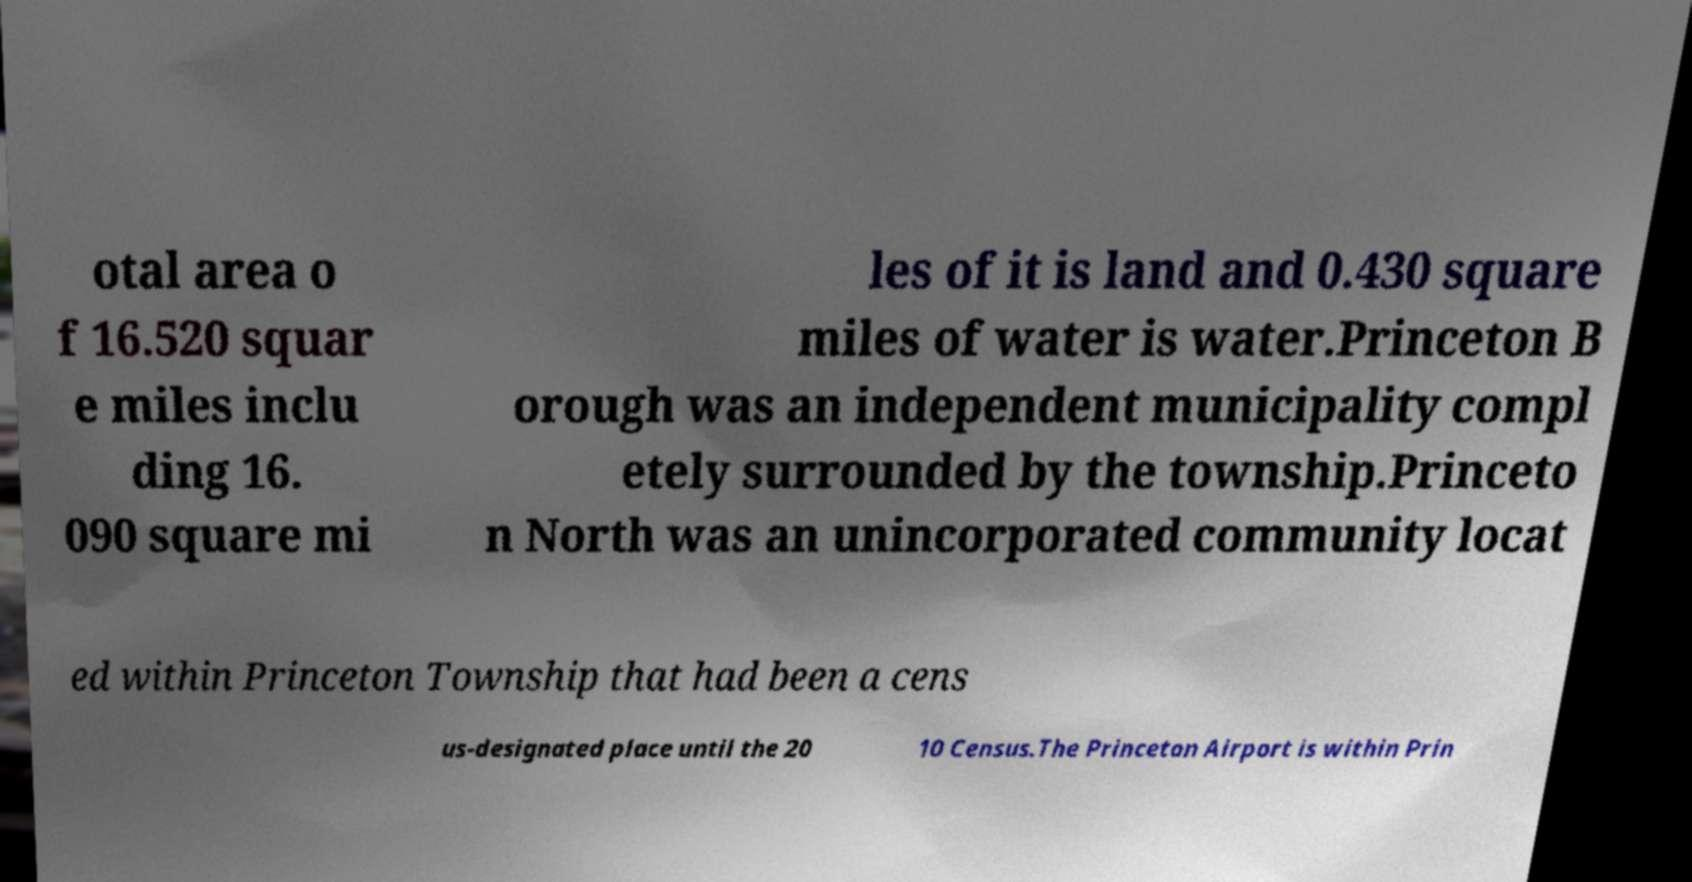Please identify and transcribe the text found in this image. otal area o f 16.520 squar e miles inclu ding 16. 090 square mi les of it is land and 0.430 square miles of water is water.Princeton B orough was an independent municipality compl etely surrounded by the township.Princeto n North was an unincorporated community locat ed within Princeton Township that had been a cens us-designated place until the 20 10 Census.The Princeton Airport is within Prin 